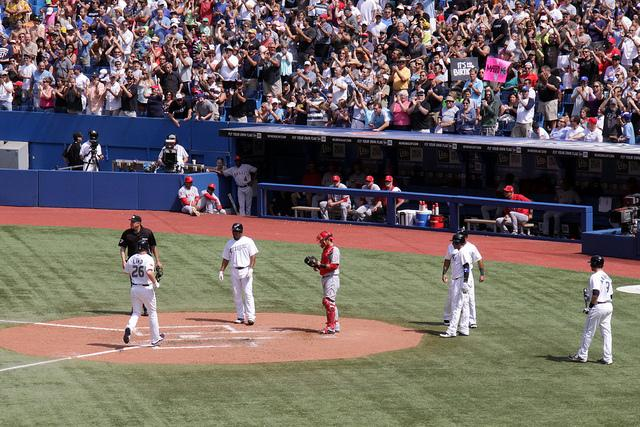What position is the man in red kneepads on the field playing?

Choices:
A) catcher
B) umpire
C) outfielder
D) first base catcher 